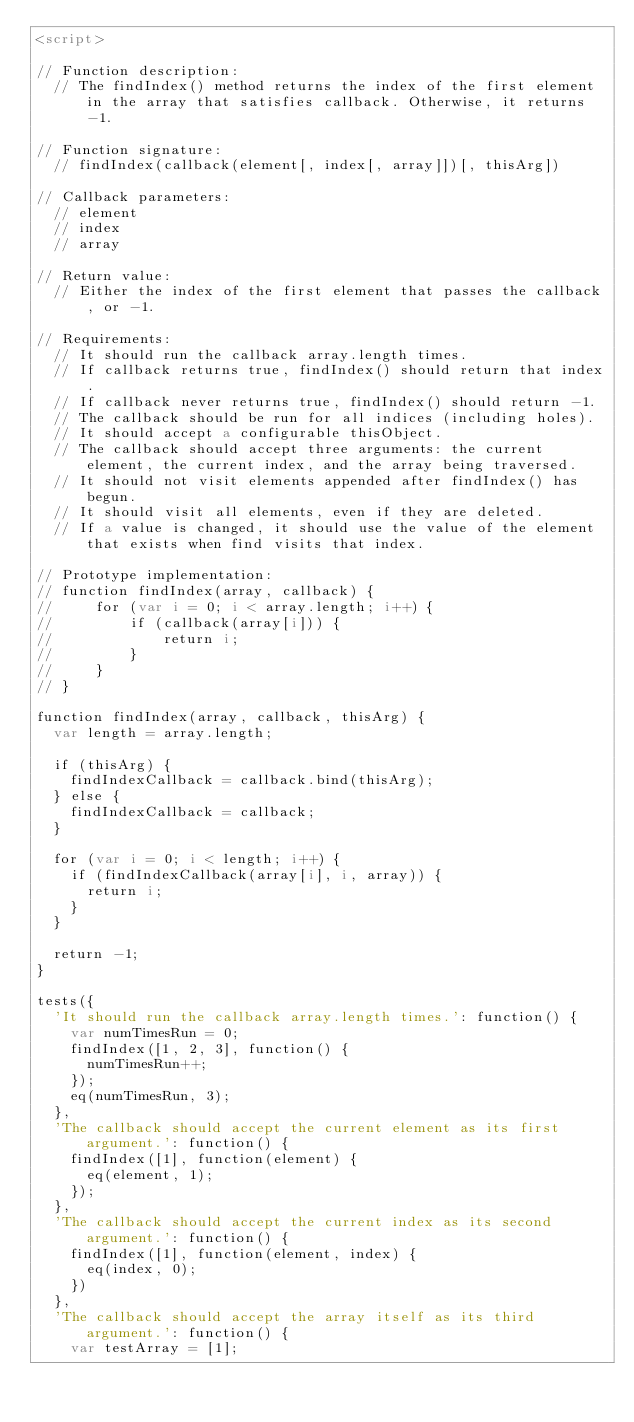<code> <loc_0><loc_0><loc_500><loc_500><_HTML_><script>

// Function description:
  // The findIndex() method returns the index of the first element in the array that satisfies callback. Otherwise, it returns -1.

// Function signature:
  // findIndex(callback(element[, index[, array]])[, thisArg])

// Callback parameters:
  // element
  // index
  // array

// Return value:
  // Either the index of the first element that passes the callback, or -1.

// Requirements:
  // It should run the callback array.length times.
  // If callback returns true, findIndex() should return that index.
  // If callback never returns true, findIndex() should return -1.
  // The callback should be run for all indices (including holes).
  // It should accept a configurable thisObject.
  // The callback should accept three arguments: the current element, the current index, and the array being traversed.
  // It should not visit elements appended after findIndex() has begun.
  // It should visit all elements, even if they are deleted.
  // If a value is changed, it should use the value of the element that exists when find visits that index.

// Prototype implementation:
// function findIndex(array, callback) {
//     for (var i = 0; i < array.length; i++) {
//         if (callback(array[i])) {
//             return i;
//         }
//     }
// }

function findIndex(array, callback, thisArg) {
  var length = array.length;
  
  if (thisArg) {
    findIndexCallback = callback.bind(thisArg);
  } else {
    findIndexCallback = callback;
  }
  
  for (var i = 0; i < length; i++) {
    if (findIndexCallback(array[i], i, array)) {
      return i;
    }
  }

  return -1;
}

tests({
  'It should run the callback array.length times.': function() {
    var numTimesRun = 0;
    findIndex([1, 2, 3], function() {
      numTimesRun++;
    });
    eq(numTimesRun, 3);
  },
  'The callback should accept the current element as its first argument.': function() {
    findIndex([1], function(element) {
      eq(element, 1);
    });
  },
  'The callback should accept the current index as its second argument.': function() {
    findIndex([1], function(element, index) {
      eq(index, 0);
    })
  },
  'The callback should accept the array itself as its third argument.': function() {
    var testArray = [1];</code> 